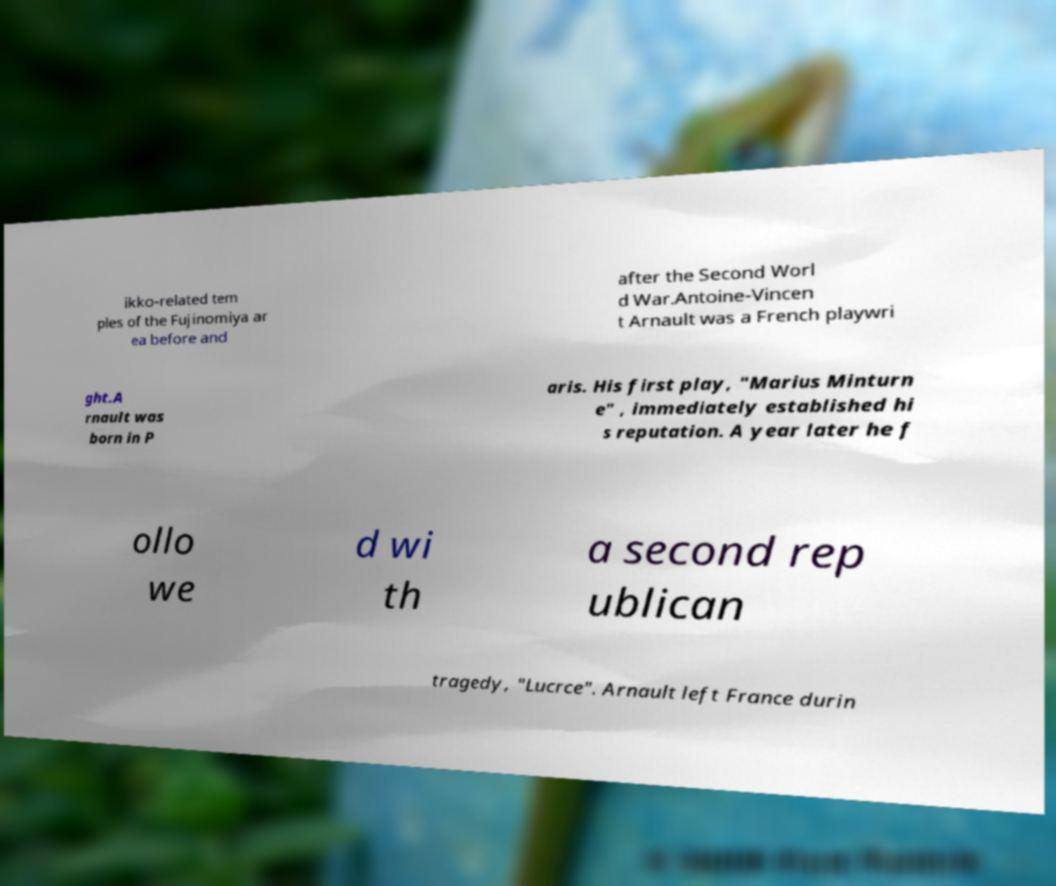I need the written content from this picture converted into text. Can you do that? ikko-related tem ples of the Fujinomiya ar ea before and after the Second Worl d War.Antoine-Vincen t Arnault was a French playwri ght.A rnault was born in P aris. His first play, "Marius Minturn e" , immediately established hi s reputation. A year later he f ollo we d wi th a second rep ublican tragedy, "Lucrce". Arnault left France durin 